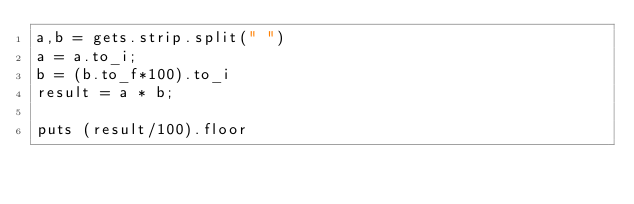<code> <loc_0><loc_0><loc_500><loc_500><_Ruby_>a,b = gets.strip.split(" ")
a = a.to_i;
b = (b.to_f*100).to_i
result = a * b;

puts (result/100).floor</code> 